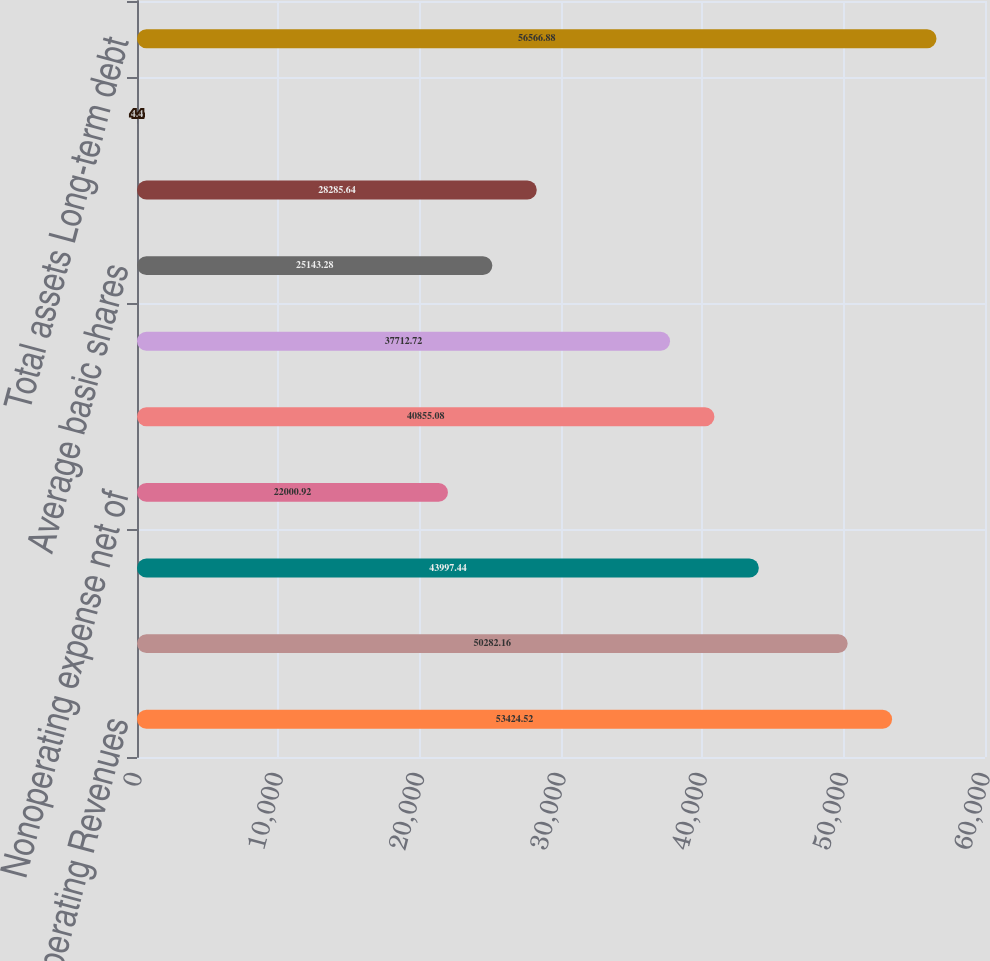<chart> <loc_0><loc_0><loc_500><loc_500><bar_chart><fcel>Operating Revenues<fcel>Operating Expenses<fcel>Operating Income (Loss)<fcel>Nonoperating expense net of<fcel>Income (loss) before income<fcel>Net Income (Loss)<fcel>Average basic shares<fcel>Average diluted shares<fcel>Diluted earnings (loss) per<fcel>Total assets Long-term debt<nl><fcel>53424.5<fcel>50282.2<fcel>43997.4<fcel>22000.9<fcel>40855.1<fcel>37712.7<fcel>25143.3<fcel>28285.6<fcel>4.4<fcel>56566.9<nl></chart> 